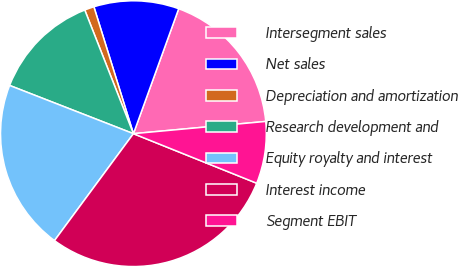Convert chart to OTSL. <chart><loc_0><loc_0><loc_500><loc_500><pie_chart><fcel>Intersegment sales<fcel>Net sales<fcel>Depreciation and amortization<fcel>Research development and<fcel>Equity royalty and interest<fcel>Interest income<fcel>Segment EBIT<nl><fcel>18.0%<fcel>10.34%<fcel>1.16%<fcel>13.12%<fcel>20.79%<fcel>29.04%<fcel>7.55%<nl></chart> 